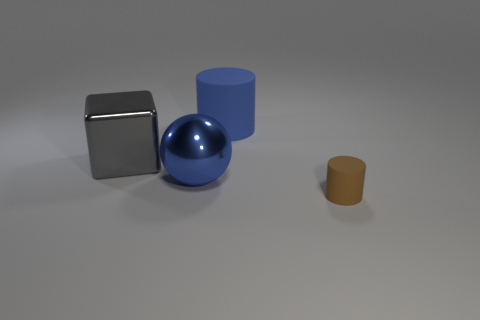How many tiny matte objects are there?
Your answer should be compact. 1. Are there fewer cyan matte balls than tiny cylinders?
Provide a succinct answer. Yes. There is a blue cylinder that is the same size as the sphere; what is its material?
Make the answer very short. Rubber. How many things are either big red matte objects or metallic balls?
Offer a very short reply. 1. How many matte cylinders are both in front of the blue rubber thing and left of the small brown object?
Your answer should be very brief. 0. Are there fewer blue shiny spheres that are on the left side of the big blue matte cylinder than big brown matte balls?
Provide a short and direct response. No. What is the shape of the blue object that is the same size as the blue cylinder?
Provide a succinct answer. Sphere. How many other objects are there of the same color as the large metal sphere?
Your response must be concise. 1. Is the blue metallic ball the same size as the gray thing?
Offer a terse response. Yes. What number of objects are either gray cylinders or tiny brown objects on the right side of the shiny sphere?
Ensure brevity in your answer.  1. 